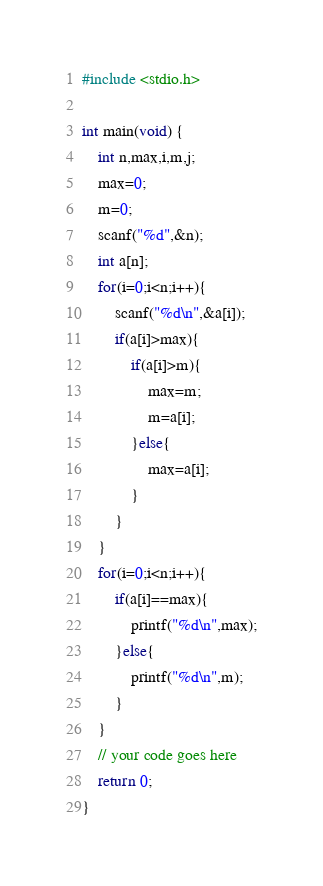Convert code to text. <code><loc_0><loc_0><loc_500><loc_500><_C_>#include <stdio.h>

int main(void) {
	int n,max,i,m,j;
	max=0;
	m=0;
	scanf("%d",&n);
	int a[n];
	for(i=0;i<n;i++){
		scanf("%d\n",&a[i]);
		if(a[i]>max){
			if(a[i]>m){
				max=m;
				m=a[i];
			}else{
				max=a[i];
			}
		}
	}
	for(i=0;i<n;i++){
		if(a[i]==max){
			printf("%d\n",max);
		}else{
			printf("%d\n",m);
		}
	}
	// your code goes here
	return 0;
}


</code> 